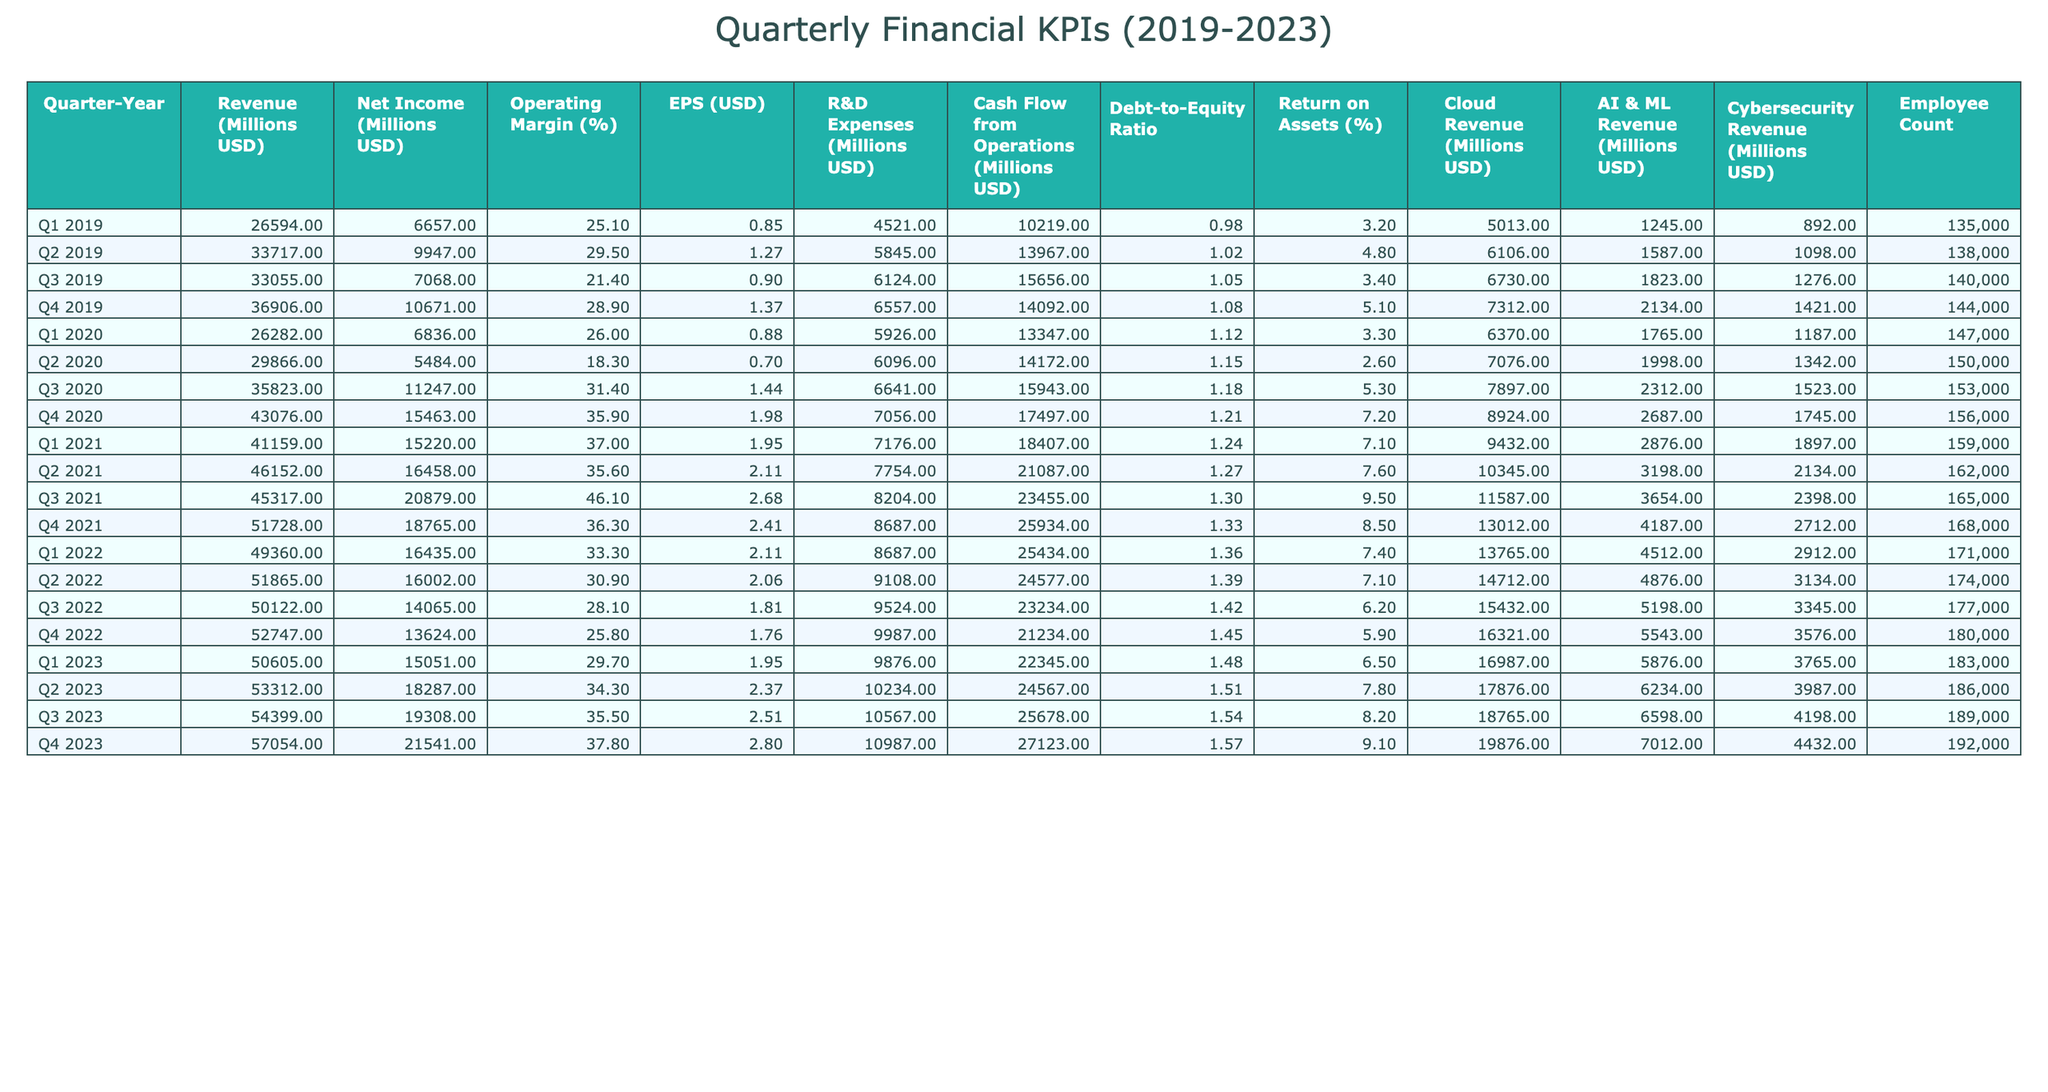What was the highest revenue recorded in 2021? Looking at the table, the revenues for each quarter in 2021 are 41159, 46152, 45317, and 51728 million USD. The highest among these is 51728 million USD in Q4 2021.
Answer: 51728 million USD What was the net income in Q3 2022? The net income for Q3 2022 is clearly stated in the table as 14065 million USD.
Answer: 14065 million USD Was the operating margin in Q4 2020 higher than in Q1 2020? In Q4 2020, the operating margin is 35.9%, while in Q1 2020 it is 26.0%. Since 35.9% is greater than 26.0%, the statement is true.
Answer: Yes What is the total R&D expenses for the year 2023? R&D expenses for the quarters in 2023 are 9876, 10234, 10567, and 10987 million USD. Summing these: 9876 + 10234 + 10567 + 10987 = 40664 million USD.
Answer: 40664 million USD What was the average EPS over all quarters in 2022? The EPS values for 2022 are 2.11, 2.06, 1.81, and 1.76. To find the average, sum these values: 2.11 + 2.06 + 1.81 + 1.76 = 7.74, then divide by 4 (quarters), giving 7.74 / 4 = 1.935.
Answer: 1.935 Did the debt-to-equity ratio increase from Q1 2020 to Q4 2020? The debt-to-equity ratios are 1.12 for Q1 2020 and 1.21 for Q4 2020. Since 1.21 > 1.12, we can confirm that the ratio did indeed increase.
Answer: Yes What year had the highest cloud revenue and what was that amount? Going through the cloud revenues, the values per year in 2023 are the maximum at 19876 million USD (Q4 2023), which is the highest across all years.
Answer: 19876 million USD in 2023 What was the total cash flow from operations in 2020? For 2020, the cash flow values are 13347, 14172, 15943, and 17497 million USD. Adding these gives: 13347 + 14172 + 15943 + 17497 = 60959 million USD total for the year.
Answer: 60959 million USD Which quarter in 2019 had the lowest net income? The net income figures for each quarter in 2019 are 6657, 9947, 7068, and 10671 million USD. The lowest is 6657 million USD in Q1 2019.
Answer: 6657 million USD Were employee counts greater in Q3 2021 or Q4 2021? The employee counts for Q3 2021 and Q4 2021 are 165000 and 168000 respectively. Since 168000 > 165000, we conclude Q4 2021 had a greater count.
Answer: Q4 2021 had a greater count 